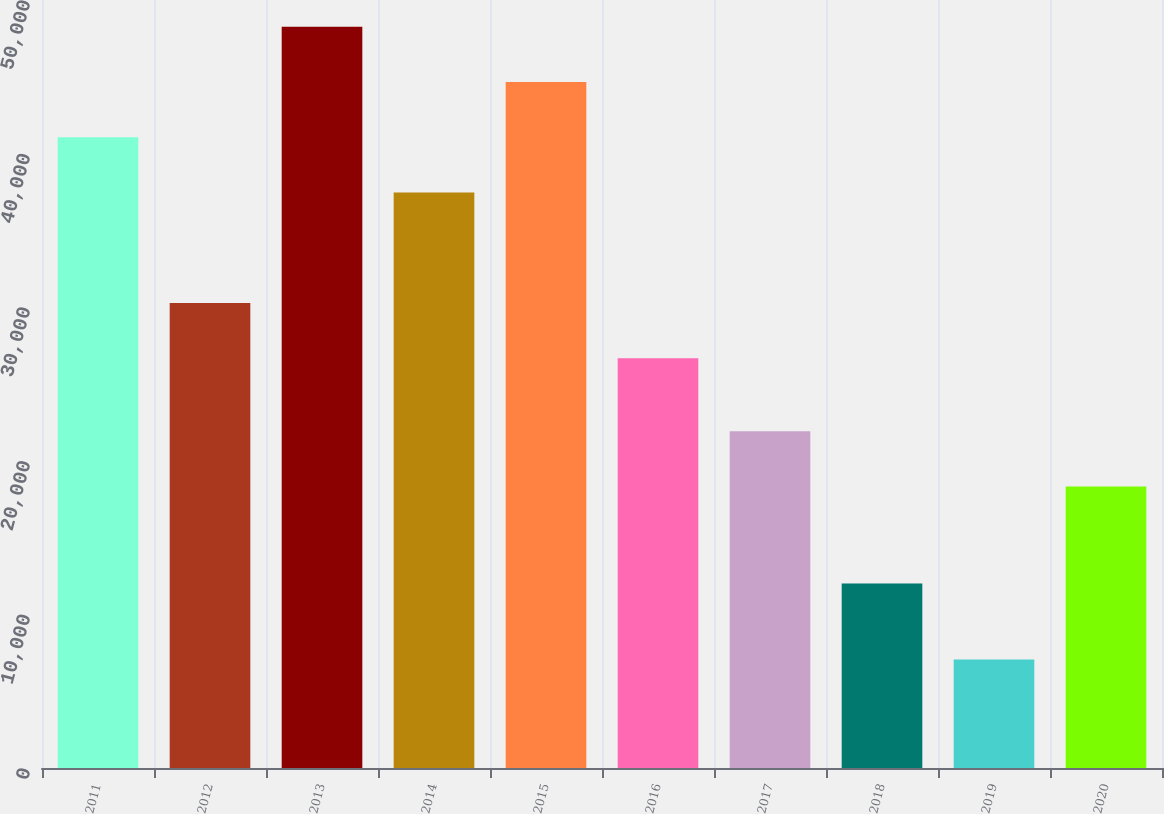Convert chart. <chart><loc_0><loc_0><loc_500><loc_500><bar_chart><fcel>2011<fcel>2012<fcel>2013<fcel>2014<fcel>2015<fcel>2016<fcel>2017<fcel>2018<fcel>2019<fcel>2020<nl><fcel>41060.6<fcel>30271.4<fcel>48253.4<fcel>37464.2<fcel>44657<fcel>26675<fcel>21921.4<fcel>12008<fcel>7067<fcel>18325<nl></chart> 